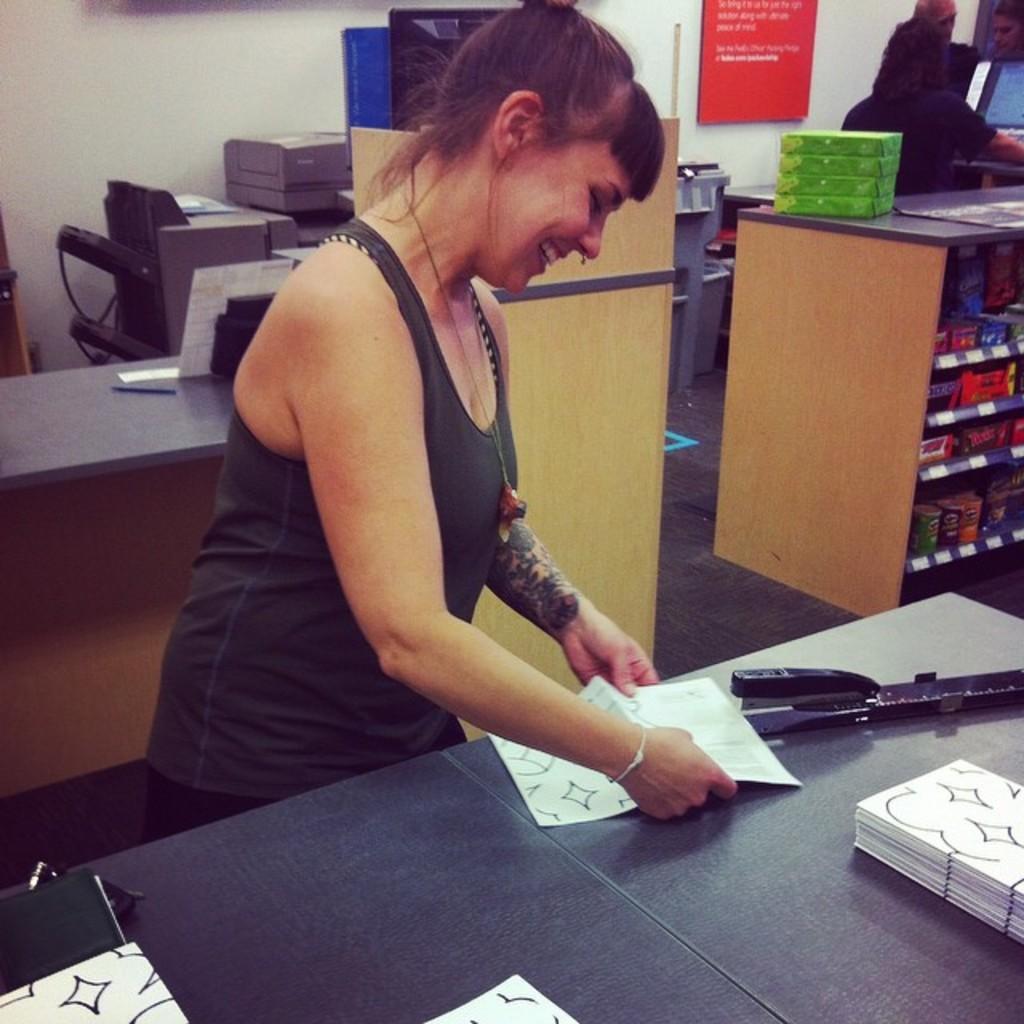Describe this image in one or two sentences. In the picture we can find a woman is standing near the table and smiling. In the background we can see some tables and one person and wall. And the woman is preparing something with the paper. 